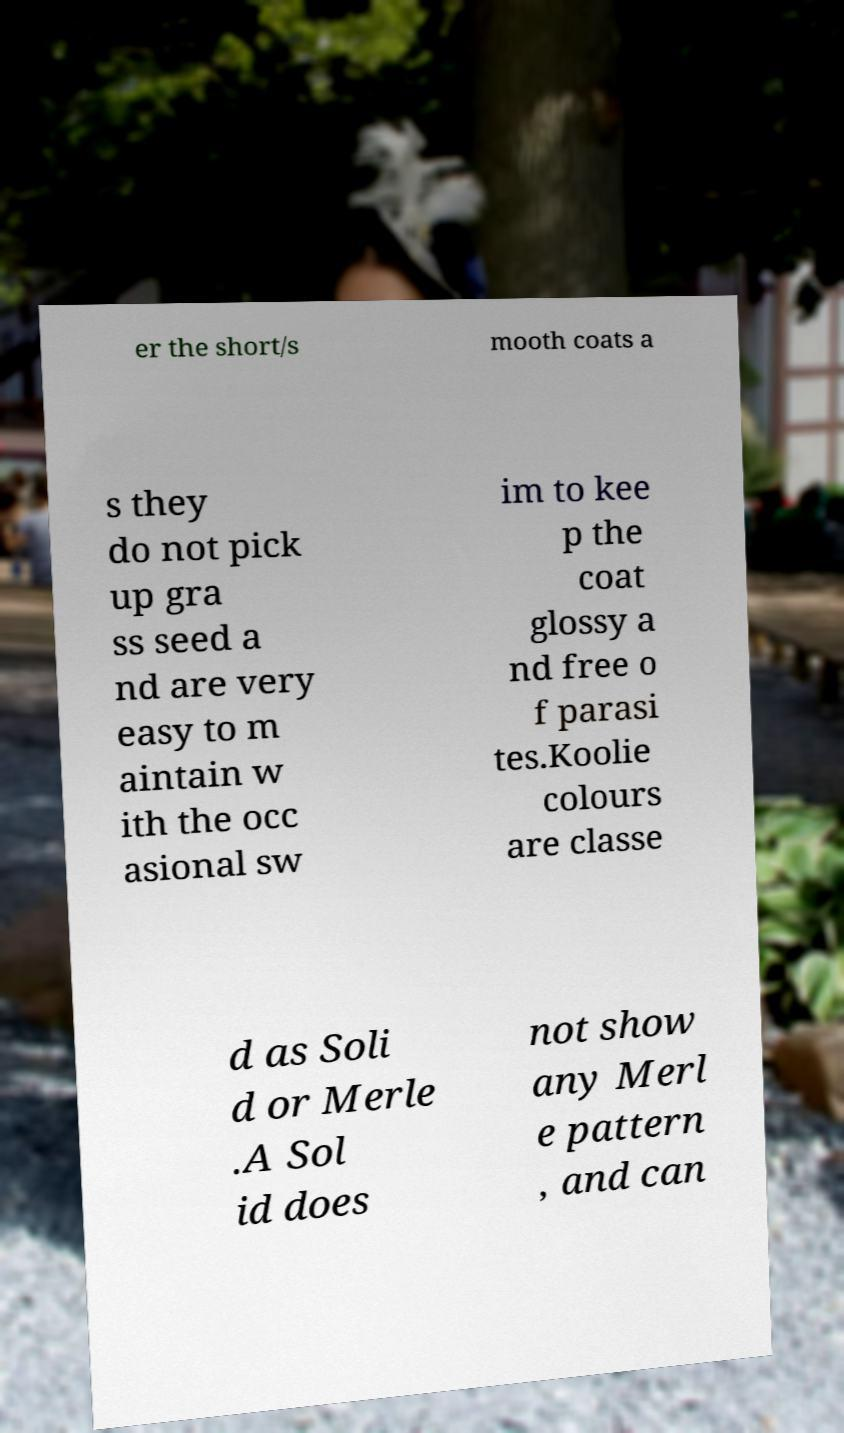There's text embedded in this image that I need extracted. Can you transcribe it verbatim? er the short/s mooth coats a s they do not pick up gra ss seed a nd are very easy to m aintain w ith the occ asional sw im to kee p the coat glossy a nd free o f parasi tes.Koolie colours are classe d as Soli d or Merle .A Sol id does not show any Merl e pattern , and can 